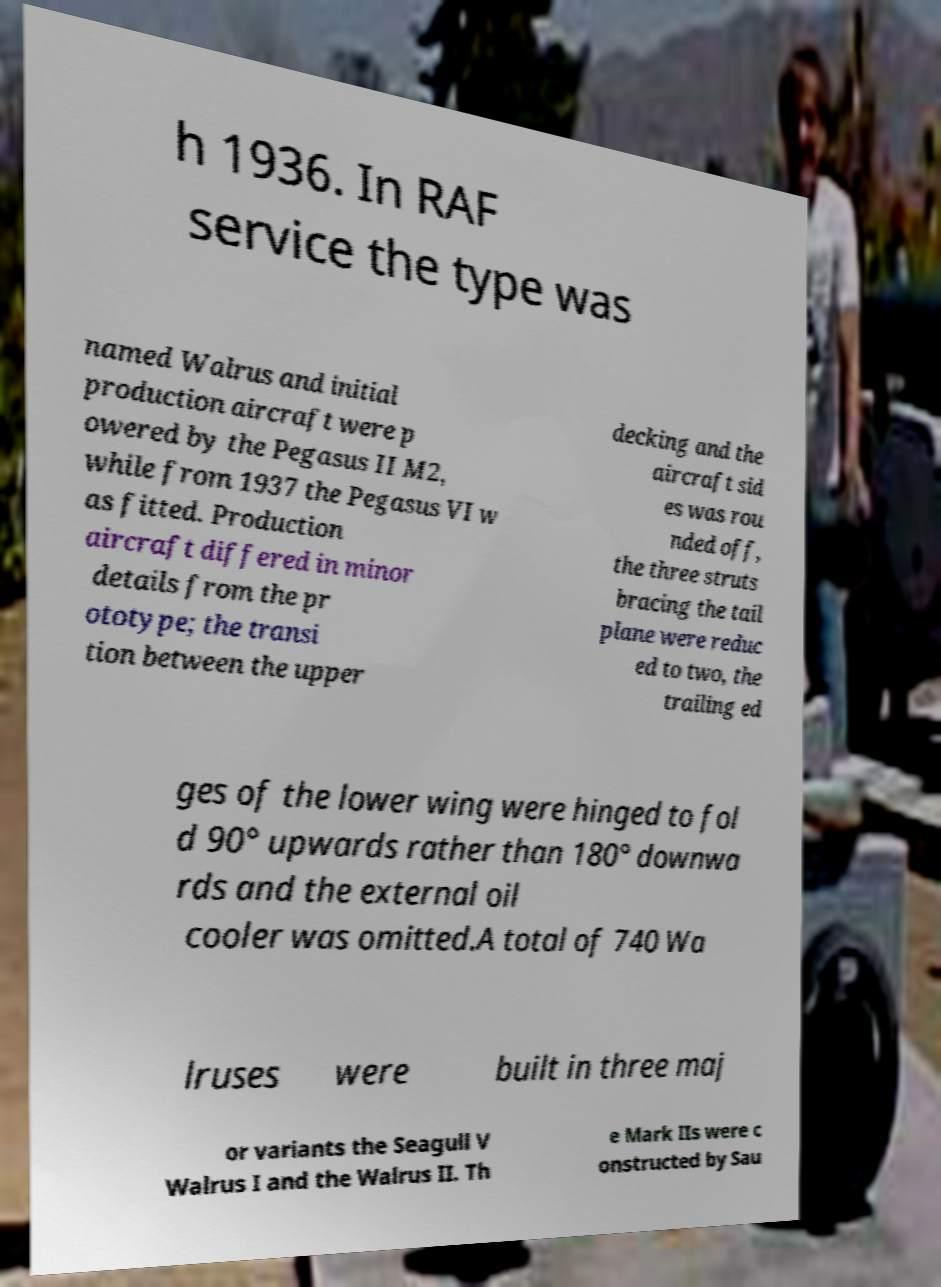I need the written content from this picture converted into text. Can you do that? h 1936. In RAF service the type was named Walrus and initial production aircraft were p owered by the Pegasus II M2, while from 1937 the Pegasus VI w as fitted. Production aircraft differed in minor details from the pr ototype; the transi tion between the upper decking and the aircraft sid es was rou nded off, the three struts bracing the tail plane were reduc ed to two, the trailing ed ges of the lower wing were hinged to fol d 90° upwards rather than 180° downwa rds and the external oil cooler was omitted.A total of 740 Wa lruses were built in three maj or variants the Seagull V Walrus I and the Walrus II. Th e Mark IIs were c onstructed by Sau 